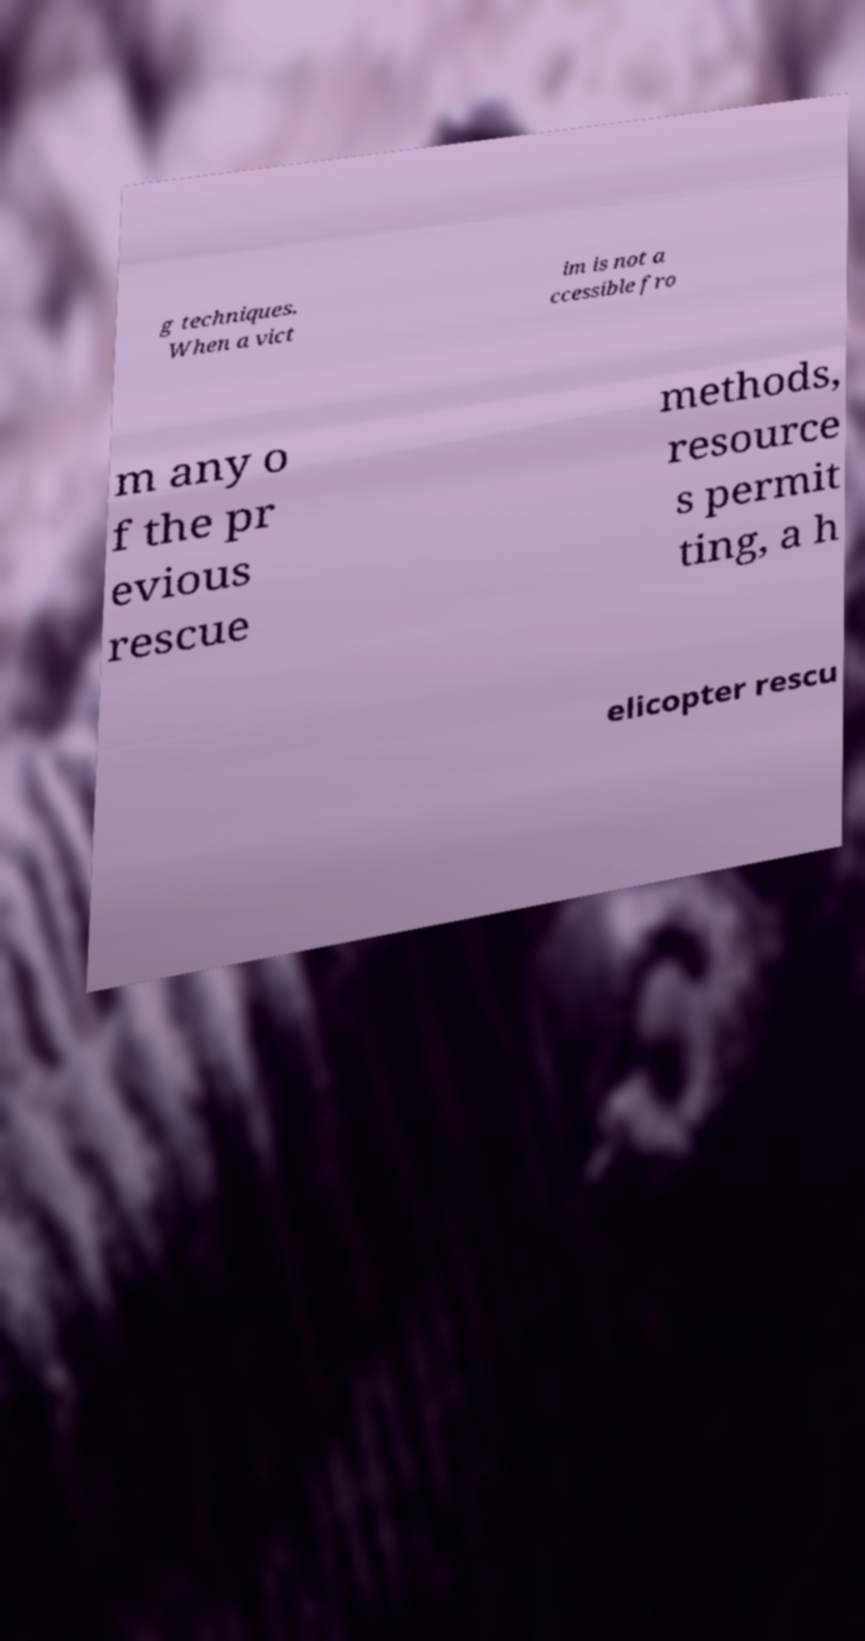I need the written content from this picture converted into text. Can you do that? g techniques. When a vict im is not a ccessible fro m any o f the pr evious rescue methods, resource s permit ting, a h elicopter rescu 